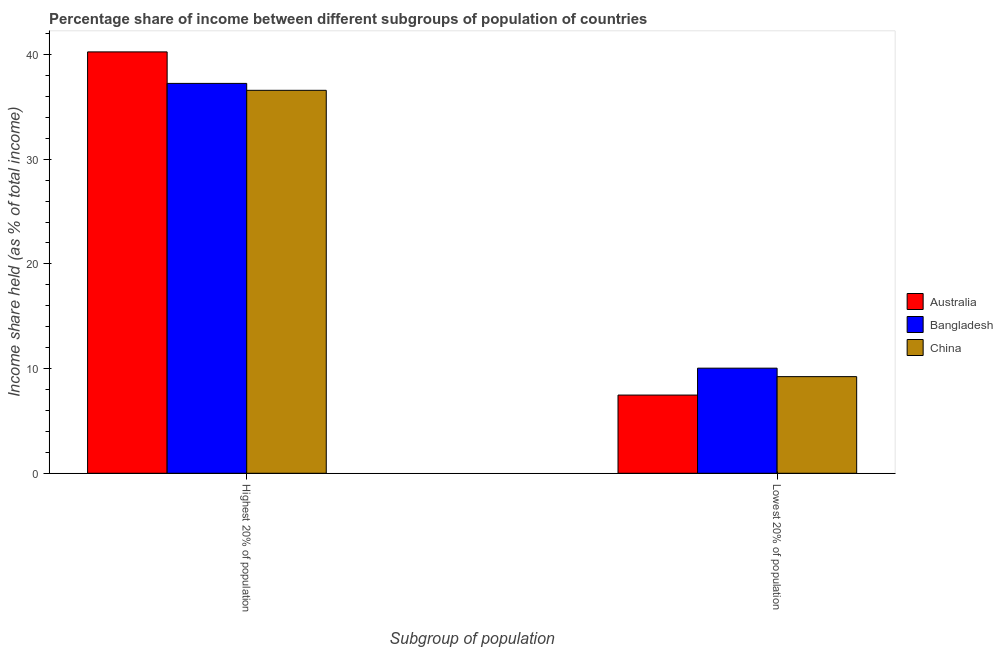How many different coloured bars are there?
Your answer should be very brief. 3. What is the label of the 2nd group of bars from the left?
Your answer should be compact. Lowest 20% of population. What is the income share held by highest 20% of the population in Australia?
Your response must be concise. 40.25. Across all countries, what is the maximum income share held by highest 20% of the population?
Your answer should be compact. 40.25. Across all countries, what is the minimum income share held by lowest 20% of the population?
Ensure brevity in your answer.  7.47. In which country was the income share held by lowest 20% of the population minimum?
Your answer should be very brief. Australia. What is the total income share held by highest 20% of the population in the graph?
Your answer should be very brief. 114.07. What is the difference between the income share held by highest 20% of the population in Australia and that in China?
Your response must be concise. 3.67. What is the difference between the income share held by lowest 20% of the population in China and the income share held by highest 20% of the population in Bangladesh?
Provide a short and direct response. -28.01. What is the average income share held by lowest 20% of the population per country?
Make the answer very short. 8.91. What is the difference between the income share held by highest 20% of the population and income share held by lowest 20% of the population in Bangladesh?
Give a very brief answer. 27.2. What is the ratio of the income share held by highest 20% of the population in China to that in Australia?
Keep it short and to the point. 0.91. In how many countries, is the income share held by highest 20% of the population greater than the average income share held by highest 20% of the population taken over all countries?
Keep it short and to the point. 1. What does the 2nd bar from the left in Lowest 20% of population represents?
Offer a terse response. Bangladesh. What is the difference between two consecutive major ticks on the Y-axis?
Make the answer very short. 10. Are the values on the major ticks of Y-axis written in scientific E-notation?
Your answer should be compact. No. How many legend labels are there?
Your answer should be very brief. 3. How are the legend labels stacked?
Provide a short and direct response. Vertical. What is the title of the graph?
Your answer should be compact. Percentage share of income between different subgroups of population of countries. What is the label or title of the X-axis?
Keep it short and to the point. Subgroup of population. What is the label or title of the Y-axis?
Your answer should be very brief. Income share held (as % of total income). What is the Income share held (as % of total income) of Australia in Highest 20% of population?
Your answer should be very brief. 40.25. What is the Income share held (as % of total income) in Bangladesh in Highest 20% of population?
Give a very brief answer. 37.24. What is the Income share held (as % of total income) of China in Highest 20% of population?
Your answer should be compact. 36.58. What is the Income share held (as % of total income) in Australia in Lowest 20% of population?
Your answer should be very brief. 7.47. What is the Income share held (as % of total income) of Bangladesh in Lowest 20% of population?
Provide a succinct answer. 10.04. What is the Income share held (as % of total income) in China in Lowest 20% of population?
Provide a succinct answer. 9.23. Across all Subgroup of population, what is the maximum Income share held (as % of total income) in Australia?
Give a very brief answer. 40.25. Across all Subgroup of population, what is the maximum Income share held (as % of total income) in Bangladesh?
Give a very brief answer. 37.24. Across all Subgroup of population, what is the maximum Income share held (as % of total income) of China?
Provide a succinct answer. 36.58. Across all Subgroup of population, what is the minimum Income share held (as % of total income) of Australia?
Offer a terse response. 7.47. Across all Subgroup of population, what is the minimum Income share held (as % of total income) of Bangladesh?
Give a very brief answer. 10.04. Across all Subgroup of population, what is the minimum Income share held (as % of total income) of China?
Provide a succinct answer. 9.23. What is the total Income share held (as % of total income) in Australia in the graph?
Provide a short and direct response. 47.72. What is the total Income share held (as % of total income) of Bangladesh in the graph?
Ensure brevity in your answer.  47.28. What is the total Income share held (as % of total income) in China in the graph?
Your answer should be very brief. 45.81. What is the difference between the Income share held (as % of total income) in Australia in Highest 20% of population and that in Lowest 20% of population?
Your answer should be compact. 32.78. What is the difference between the Income share held (as % of total income) of Bangladesh in Highest 20% of population and that in Lowest 20% of population?
Your response must be concise. 27.2. What is the difference between the Income share held (as % of total income) of China in Highest 20% of population and that in Lowest 20% of population?
Provide a short and direct response. 27.35. What is the difference between the Income share held (as % of total income) in Australia in Highest 20% of population and the Income share held (as % of total income) in Bangladesh in Lowest 20% of population?
Your response must be concise. 30.21. What is the difference between the Income share held (as % of total income) of Australia in Highest 20% of population and the Income share held (as % of total income) of China in Lowest 20% of population?
Give a very brief answer. 31.02. What is the difference between the Income share held (as % of total income) of Bangladesh in Highest 20% of population and the Income share held (as % of total income) of China in Lowest 20% of population?
Your response must be concise. 28.01. What is the average Income share held (as % of total income) in Australia per Subgroup of population?
Provide a succinct answer. 23.86. What is the average Income share held (as % of total income) in Bangladesh per Subgroup of population?
Provide a succinct answer. 23.64. What is the average Income share held (as % of total income) of China per Subgroup of population?
Your response must be concise. 22.91. What is the difference between the Income share held (as % of total income) of Australia and Income share held (as % of total income) of Bangladesh in Highest 20% of population?
Your response must be concise. 3.01. What is the difference between the Income share held (as % of total income) of Australia and Income share held (as % of total income) of China in Highest 20% of population?
Offer a terse response. 3.67. What is the difference between the Income share held (as % of total income) in Bangladesh and Income share held (as % of total income) in China in Highest 20% of population?
Your response must be concise. 0.66. What is the difference between the Income share held (as % of total income) in Australia and Income share held (as % of total income) in Bangladesh in Lowest 20% of population?
Your answer should be very brief. -2.57. What is the difference between the Income share held (as % of total income) of Australia and Income share held (as % of total income) of China in Lowest 20% of population?
Keep it short and to the point. -1.76. What is the difference between the Income share held (as % of total income) of Bangladesh and Income share held (as % of total income) of China in Lowest 20% of population?
Ensure brevity in your answer.  0.81. What is the ratio of the Income share held (as % of total income) of Australia in Highest 20% of population to that in Lowest 20% of population?
Provide a short and direct response. 5.39. What is the ratio of the Income share held (as % of total income) in Bangladesh in Highest 20% of population to that in Lowest 20% of population?
Your response must be concise. 3.71. What is the ratio of the Income share held (as % of total income) in China in Highest 20% of population to that in Lowest 20% of population?
Ensure brevity in your answer.  3.96. What is the difference between the highest and the second highest Income share held (as % of total income) of Australia?
Ensure brevity in your answer.  32.78. What is the difference between the highest and the second highest Income share held (as % of total income) of Bangladesh?
Offer a terse response. 27.2. What is the difference between the highest and the second highest Income share held (as % of total income) in China?
Keep it short and to the point. 27.35. What is the difference between the highest and the lowest Income share held (as % of total income) in Australia?
Ensure brevity in your answer.  32.78. What is the difference between the highest and the lowest Income share held (as % of total income) of Bangladesh?
Provide a short and direct response. 27.2. What is the difference between the highest and the lowest Income share held (as % of total income) in China?
Provide a short and direct response. 27.35. 